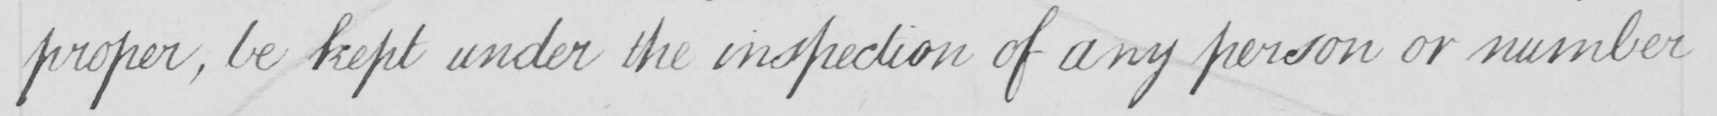Can you tell me what this handwritten text says? proper , be kept under the inspection of any person or number 